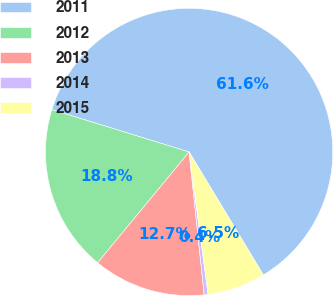<chart> <loc_0><loc_0><loc_500><loc_500><pie_chart><fcel>2011<fcel>2012<fcel>2013<fcel>2014<fcel>2015<nl><fcel>61.59%<fcel>18.78%<fcel>12.66%<fcel>0.43%<fcel>6.54%<nl></chart> 